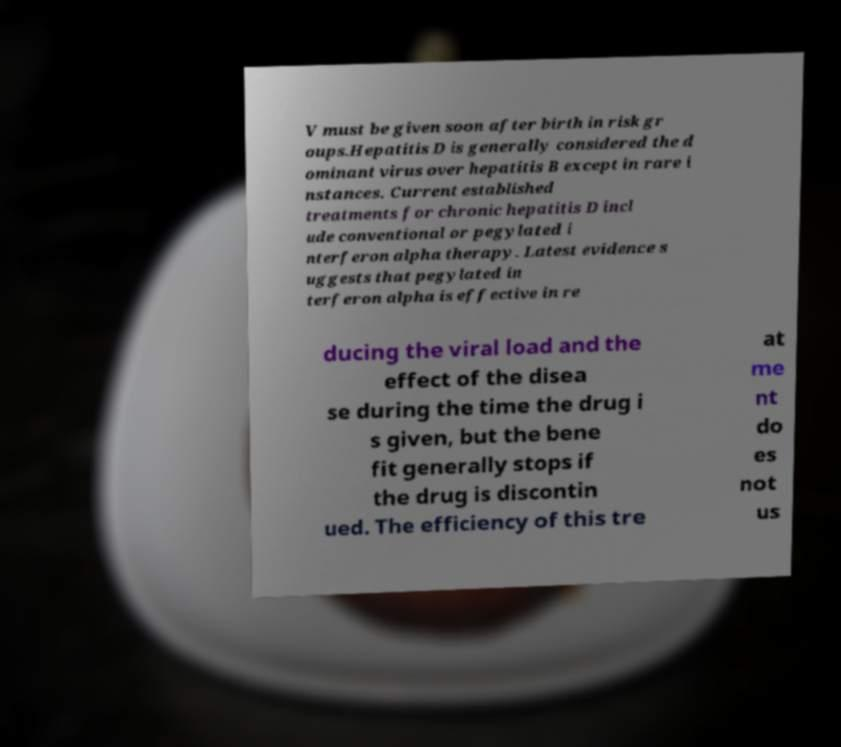What messages or text are displayed in this image? I need them in a readable, typed format. V must be given soon after birth in risk gr oups.Hepatitis D is generally considered the d ominant virus over hepatitis B except in rare i nstances. Current established treatments for chronic hepatitis D incl ude conventional or pegylated i nterferon alpha therapy. Latest evidence s uggests that pegylated in terferon alpha is effective in re ducing the viral load and the effect of the disea se during the time the drug i s given, but the bene fit generally stops if the drug is discontin ued. The efficiency of this tre at me nt do es not us 